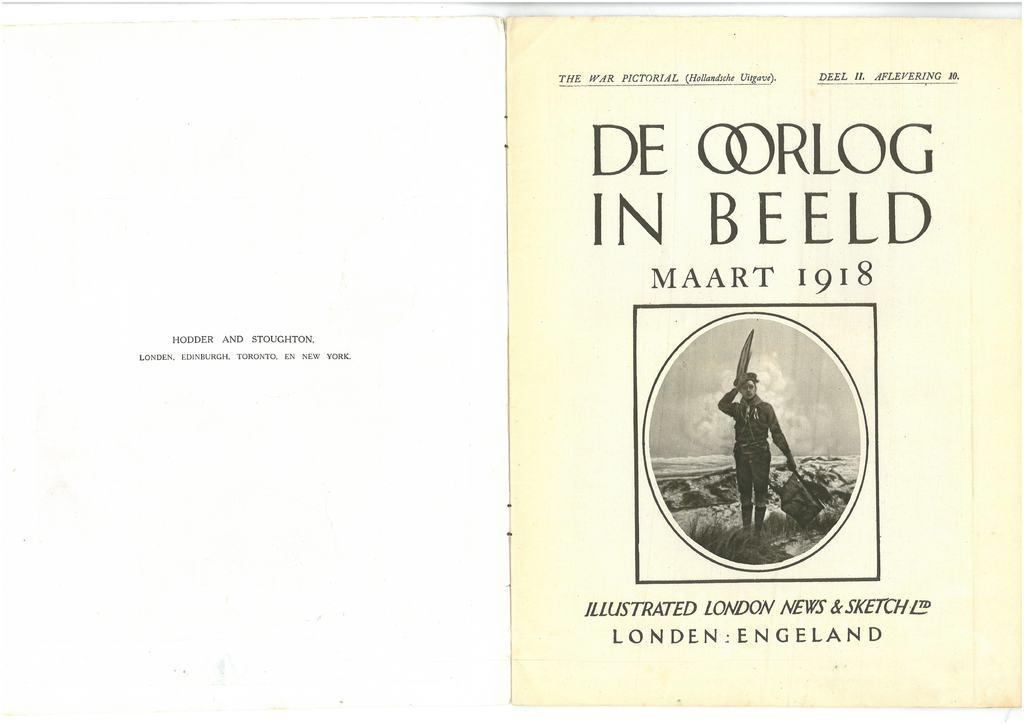Provide a one-sentence caption for the provided image. A book is open showing the first page, indicating it was illustrated by London News and Sketch. 